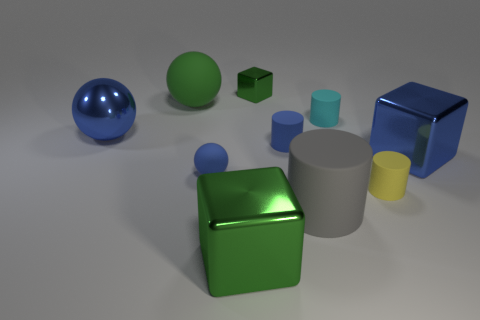Subtract all cylinders. How many objects are left? 6 Subtract all green rubber things. Subtract all metal cylinders. How many objects are left? 9 Add 4 big green spheres. How many big green spheres are left? 5 Add 6 tiny shiny blocks. How many tiny shiny blocks exist? 7 Subtract 0 cyan balls. How many objects are left? 10 